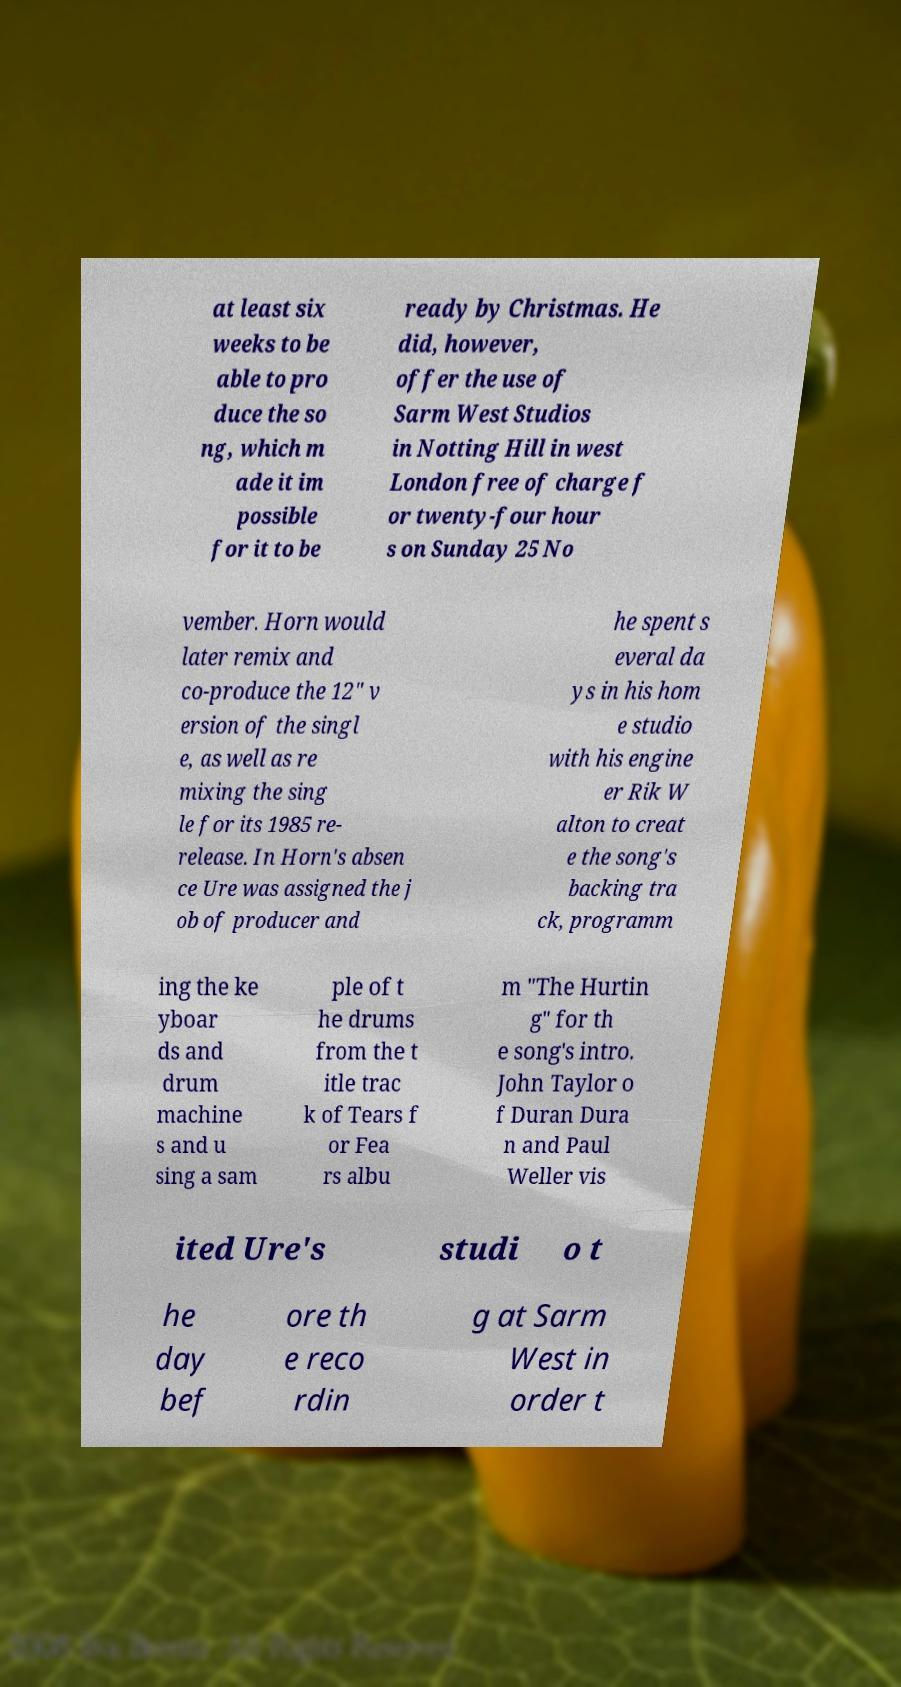I need the written content from this picture converted into text. Can you do that? at least six weeks to be able to pro duce the so ng, which m ade it im possible for it to be ready by Christmas. He did, however, offer the use of Sarm West Studios in Notting Hill in west London free of charge f or twenty-four hour s on Sunday 25 No vember. Horn would later remix and co-produce the 12" v ersion of the singl e, as well as re mixing the sing le for its 1985 re- release. In Horn's absen ce Ure was assigned the j ob of producer and he spent s everal da ys in his hom e studio with his engine er Rik W alton to creat e the song's backing tra ck, programm ing the ke yboar ds and drum machine s and u sing a sam ple of t he drums from the t itle trac k of Tears f or Fea rs albu m "The Hurtin g" for th e song's intro. John Taylor o f Duran Dura n and Paul Weller vis ited Ure's studi o t he day bef ore th e reco rdin g at Sarm West in order t 